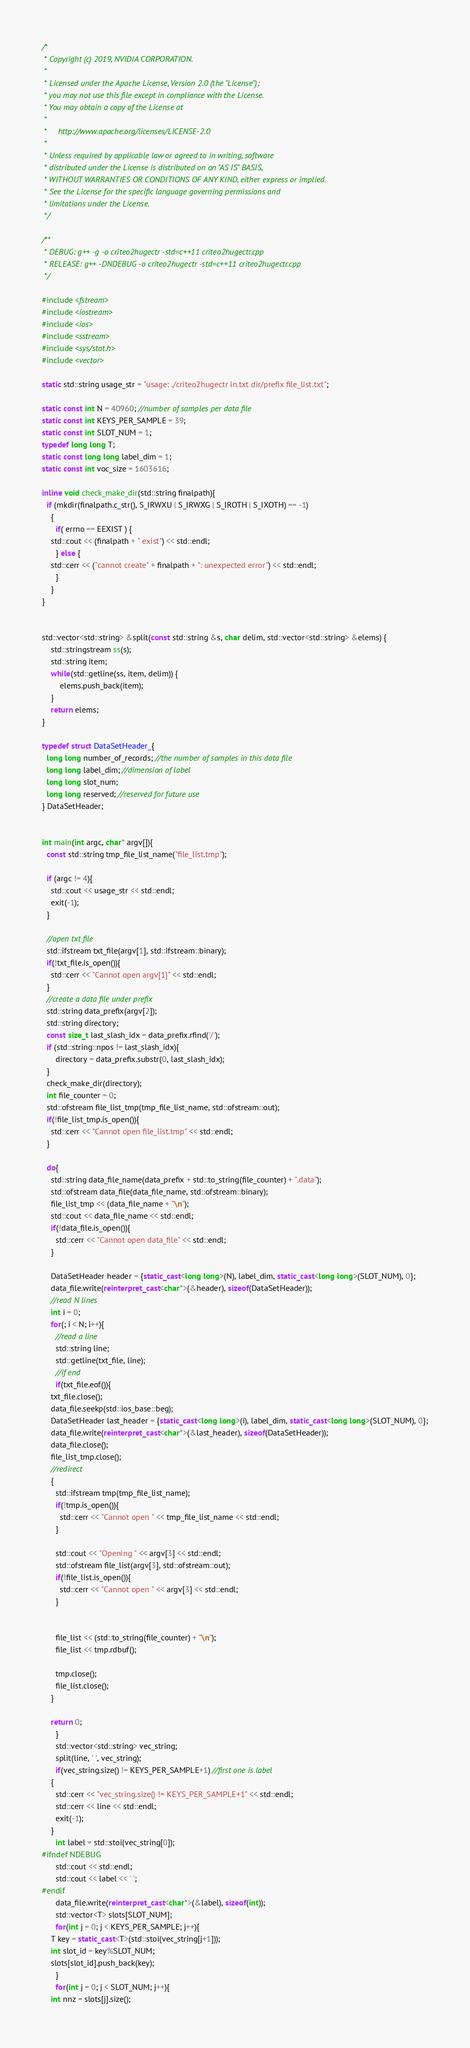Convert code to text. <code><loc_0><loc_0><loc_500><loc_500><_C++_>/*
 * Copyright (c) 2019, NVIDIA CORPORATION.
 *
 * Licensed under the Apache License, Version 2.0 (the "License");
 * you may not use this file except in compliance with the License.
 * You may obtain a copy of the License at
 *
 *     http://www.apache.org/licenses/LICENSE-2.0
 *
 * Unless required by applicable law or agreed to in writing, software
 * distributed under the License is distributed on an "AS IS" BASIS,
 * WITHOUT WARRANTIES OR CONDITIONS OF ANY KIND, either express or implied.
 * See the License for the specific language governing permissions and
 * limitations under the License.
 */

/**
 * DEBUG: g++ -g -o criteo2hugectr -std=c++11 criteo2hugectr.cpp 
 * RELEASE: g++ -DNDEBUG -o criteo2hugectr -std=c++11 criteo2hugectr.cpp 
 */

#include <fstream>
#include <iostream>
#include <ios>
#include <sstream>
#include <sys/stat.h>
#include <vector>

static std::string usage_str = "usage: ./criteo2hugectr in.txt dir/prefix file_list.txt"; 

static const int N = 40960; //number of samples per data file
static const int KEYS_PER_SAMPLE = 39;
static const int SLOT_NUM = 1;
typedef long long T;
static const long long label_dim = 1;
static const int voc_size = 1603616;

inline void check_make_dir(std::string finalpath){
  if (mkdir(finalpath.c_str(), S_IRWXU | S_IRWXG | S_IROTH | S_IXOTH) == -1)
    {
      if( errno == EEXIST ) {
	std::cout << (finalpath + " exist") << std::endl;
      } else {
	std::cerr << ("cannot create" + finalpath + ": unexpected error") << std::endl;
      }
    }
}


std::vector<std::string> &split(const std::string &s, char delim, std::vector<std::string> &elems) {
    std::stringstream ss(s);
    std::string item;
    while(std::getline(ss, item, delim)) {
        elems.push_back(item);
    }
    return elems;
}

typedef struct DataSetHeader_{
  long long number_of_records; //the number of samples in this data file
  long long label_dim; //dimension of label
  long long slot_num;
  long long reserved; //reserved for future use
} DataSetHeader;


int main(int argc, char* argv[]){
  const std::string tmp_file_list_name("file_list.tmp");

  if (argc != 4){
    std::cout << usage_str << std::endl;
    exit(-1);
  }

  //open txt file
  std::ifstream txt_file(argv[1], std::ifstream::binary);
  if(!txt_file.is_open()){
    std::cerr << "Cannot open argv[1]" << std::endl;
  }
  //create a data file under prefix
  std::string data_prefix(argv[2]);
  std::string directory;
  const size_t last_slash_idx = data_prefix.rfind('/');
  if (std::string::npos != last_slash_idx){
      directory = data_prefix.substr(0, last_slash_idx);
  }
  check_make_dir(directory);
  int file_counter = 0;
  std::ofstream file_list_tmp(tmp_file_list_name, std::ofstream::out);
  if(!file_list_tmp.is_open()){
    std::cerr << "Cannot open file_list.tmp" << std::endl;
  }

  do{
    std::string data_file_name(data_prefix + std::to_string(file_counter) + ".data");
    std::ofstream data_file(data_file_name, std::ofstream::binary);
    file_list_tmp << (data_file_name + "\n");
    std::cout << data_file_name << std::endl;
    if(!data_file.is_open()){
      std::cerr << "Cannot open data_file" << std::endl;
    }

    DataSetHeader header = {static_cast<long long>(N), label_dim, static_cast<long long>(SLOT_NUM), 0};
    data_file.write(reinterpret_cast<char*>(&header), sizeof(DataSetHeader));
    //read N lines
    int i = 0;
    for(; i < N; i++){
      //read a line
      std::string line;
      std::getline(txt_file, line);
      //if end
      if(txt_file.eof()){
	txt_file.close();
	data_file.seekp(std::ios_base::beg);
	DataSetHeader last_header = {static_cast<long long>(i), label_dim, static_cast<long long>(SLOT_NUM), 0};
	data_file.write(reinterpret_cast<char*>(&last_header), sizeof(DataSetHeader));
	data_file.close();
	file_list_tmp.close();
	//redirect
	{
	  std::ifstream tmp(tmp_file_list_name);
	  if(!tmp.is_open()){
	    std::cerr << "Cannot open " << tmp_file_list_name << std::endl;
	  }

	  std::cout << "Opening " << argv[3] << std::endl;
	  std::ofstream file_list(argv[3], std::ofstream::out);
	  if(!file_list.is_open()){
	    std::cerr << "Cannot open " << argv[3] << std::endl;
	  }

	  
	  file_list << (std::to_string(file_counter) + "\n");
	  file_list << tmp.rdbuf();

	  tmp.close();
	  file_list.close();
	}

	return 0;
      }
      std::vector<std::string> vec_string;
      split(line, ' ', vec_string);
      if(vec_string.size() != KEYS_PER_SAMPLE+1) //first one is label
	{
	  std::cerr << "vec_string.size() != KEYS_PER_SAMPLE+1" << std::endl;
	  std::cerr << line << std::endl;
	  exit(-1);
	}
      int label = std::stoi(vec_string[0]);
#ifndef NDEBUG
      std::cout << std::endl;
      std::cout << label << ' ';
#endif
      data_file.write(reinterpret_cast<char*>(&label), sizeof(int));
      std::vector<T> slots[SLOT_NUM];
      for(int j = 0; j < KEYS_PER_SAMPLE; j++){
	T key = static_cast<T>(std::stoi(vec_string[j+1]));
	int slot_id = key%SLOT_NUM;
	slots[slot_id].push_back(key);
      }
      for(int j = 0; j < SLOT_NUM; j++){
	int nnz = slots[j].size();</code> 